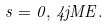<formula> <loc_0><loc_0><loc_500><loc_500>s = 0 , \, 4 j M E .</formula> 